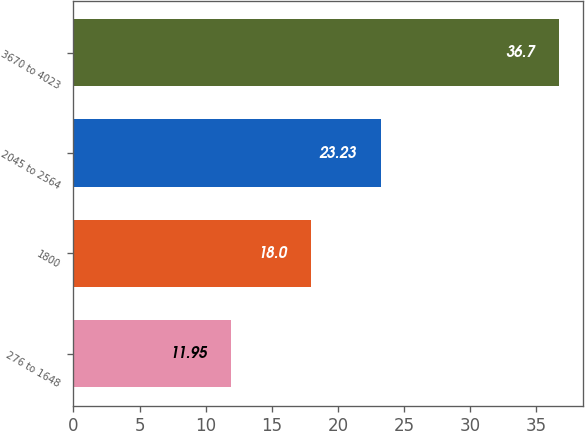<chart> <loc_0><loc_0><loc_500><loc_500><bar_chart><fcel>276 to 1648<fcel>1800<fcel>2045 to 2564<fcel>3670 to 4023<nl><fcel>11.95<fcel>18<fcel>23.23<fcel>36.7<nl></chart> 